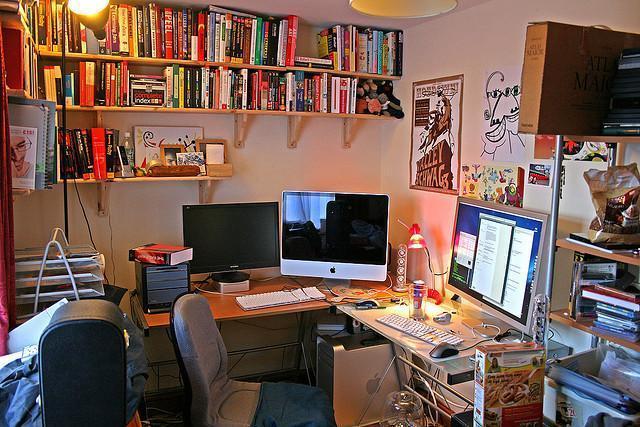How many tvs are in the photo?
Give a very brief answer. 3. How many books are in the photo?
Give a very brief answer. 1. 